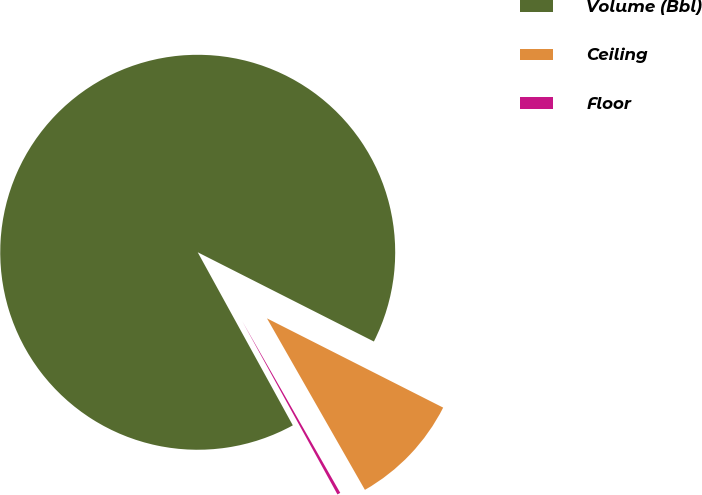Convert chart. <chart><loc_0><loc_0><loc_500><loc_500><pie_chart><fcel>Volume (Bbl)<fcel>Ceiling<fcel>Floor<nl><fcel>90.46%<fcel>9.28%<fcel>0.26%<nl></chart> 